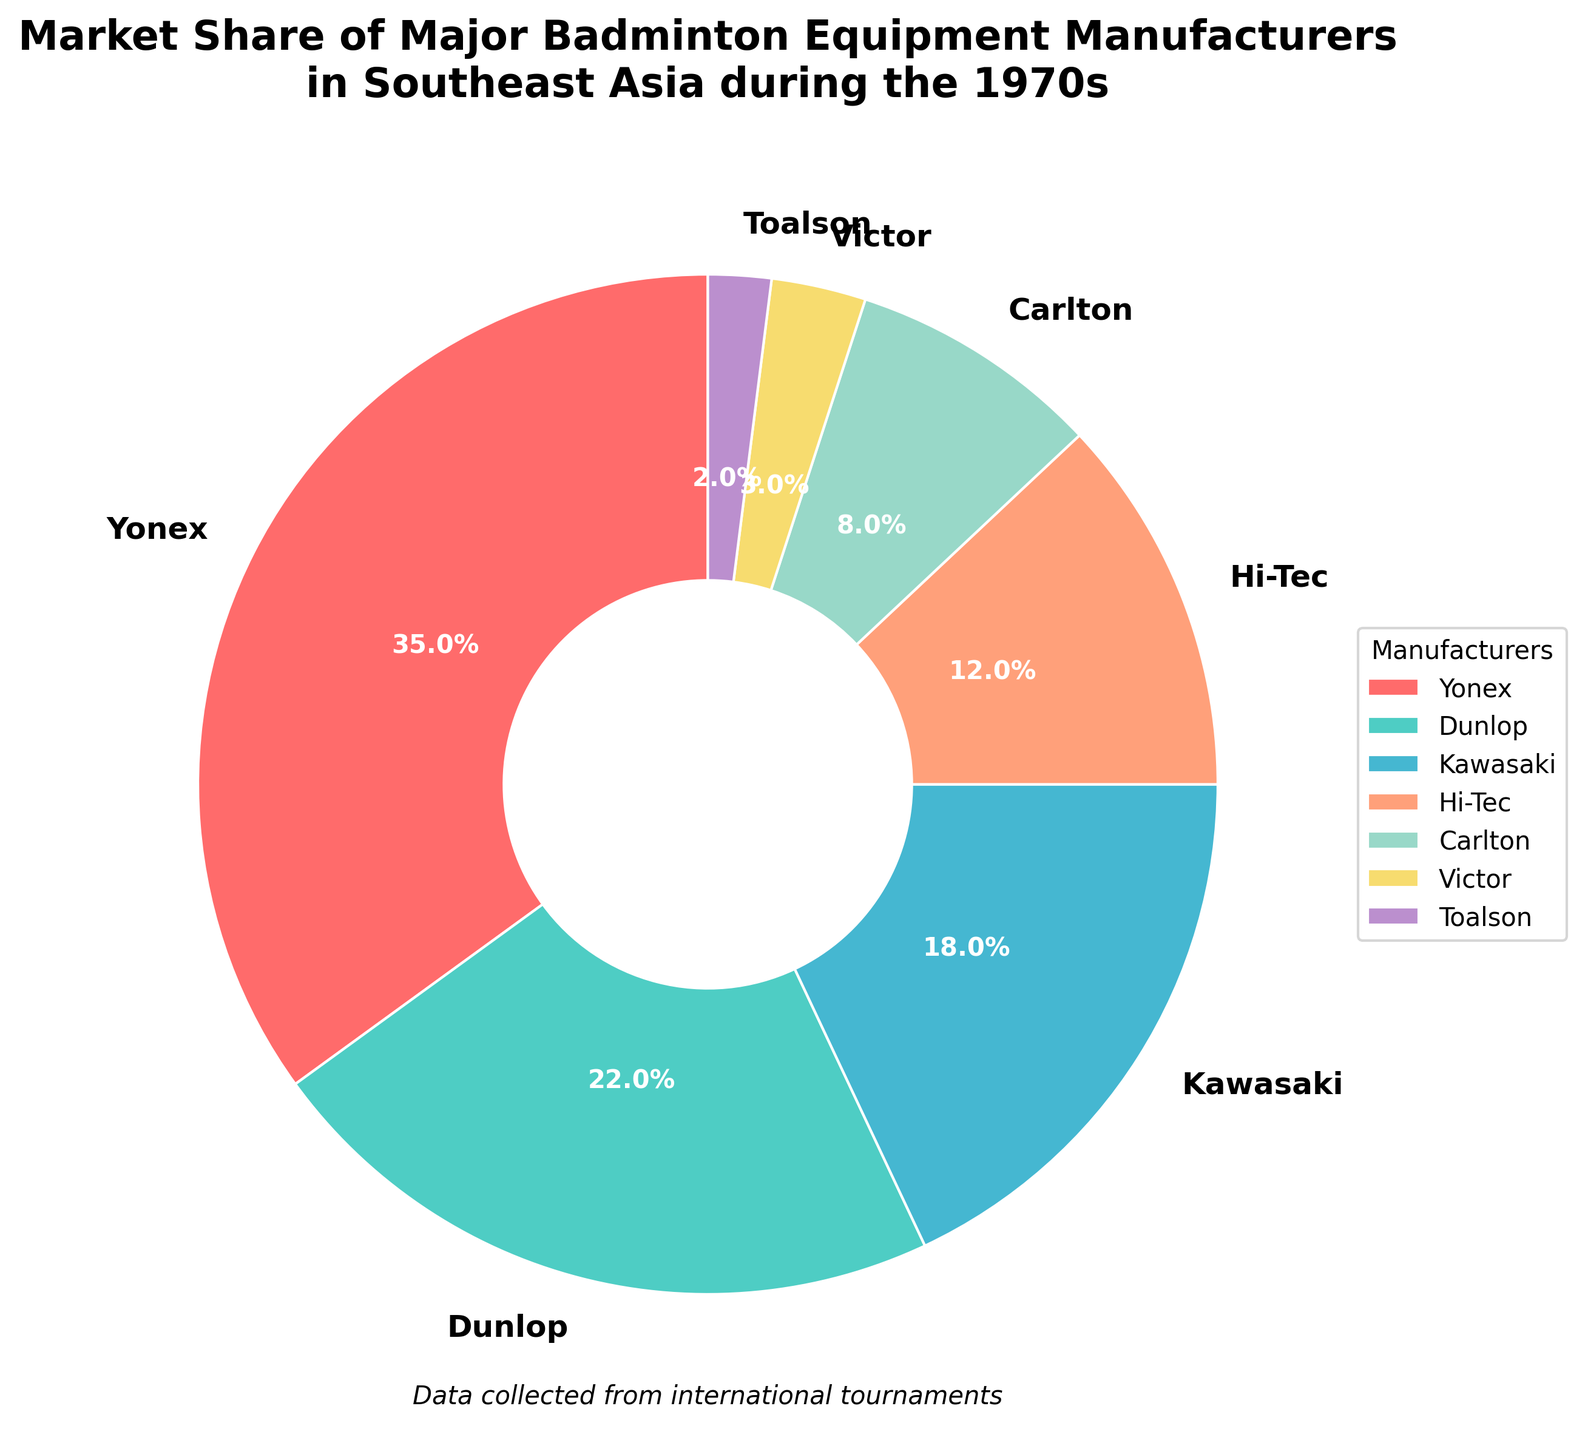What percentage of the market is controlled by Yonex and Dunlop together? The market shares of Yonex and Dunlop are 35% and 22%, respectively. Adding these together gives 35 + 22 = 57%
Answer: 57% Which manufacturer has the third largest market share? Yonex is first with 35%, Dunlop is second with 22%, and Kawasaki is third with 18%
Answer: Kawasaki Are there any manufacturers whose combined market share is less than 5%? Victor has 3% and Toalson has 2%. Adding these together gives 3 + 2 = 5%. So, no manufacturer pair has a combined market share less than 5%
Answer: No What is the difference in market share between Yonex and Hi-Tec? Yonex has a market share of 35% and Hi-Tec has 12%. The difference is 35 - 12 = 23%
Answer: 23% Which manufacturers hold less than 10% of the market? From the pie chart, Carlton, Victor, and Toalson have market shares of 8%, 3%, and 2% respectively, all under 10%
Answer: Carlton, Victor, Toalson What share of the market do the smallest three manufacturers hold collectively? Victor, Toalson, and Carlton are the smallest three manufacturers with market shares of 3%, 2%, and 8% respectively. The total is 3 + 2 + 8 = 13%
Answer: 13% Among Carlton and Hi-Tec, who has a larger market share and by how much? Hi-Tec has 12% and Carlton has 8%. The difference is 12 - 8 = 4%
Answer: Hi-Tec by 4% Which manufacturer is associated with the light blue wedge in the pie chart? The light blue wedge corresponds to the pie slice representing Kawasaki's market share
Answer: Kawasaki What is the approximate angle for the Yonex segment in the pie chart? The total angle in a pie chart is 360 degrees. Yonex controls 35% of the market. The angle is calculated as 0.35 * 360 = 126 degrees
Answer: 126 degrees If Kawasaki gained an additional 4% market share, what would their new share be and how would their rank change? Kawasaki currently has 18%. Gaining 4% would make it 18 + 4 = 22%. This would tie Kawasaki with Dunlop for the second largest market share
Answer: 22%, tied for second 